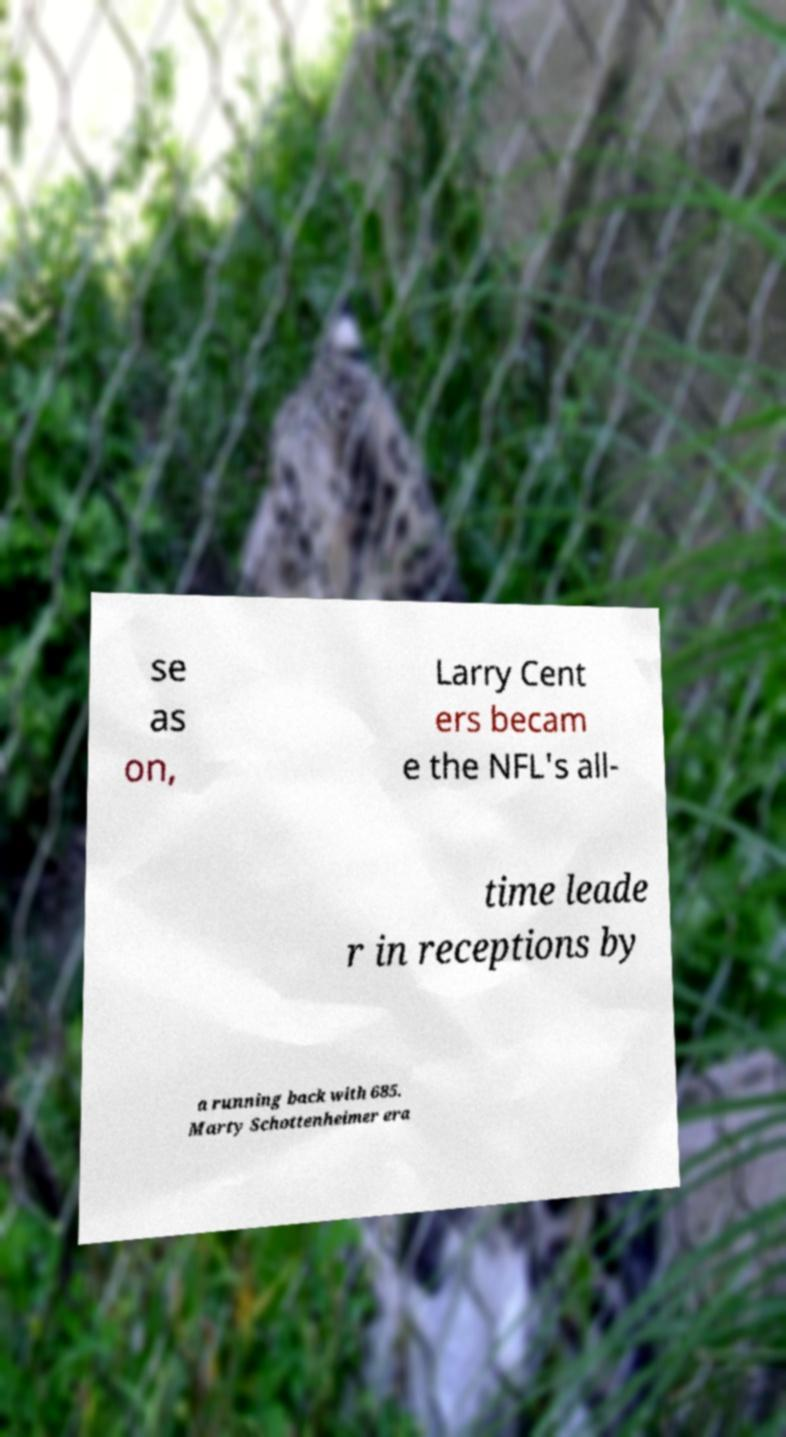I need the written content from this picture converted into text. Can you do that? se as on, Larry Cent ers becam e the NFL's all- time leade r in receptions by a running back with 685. Marty Schottenheimer era 